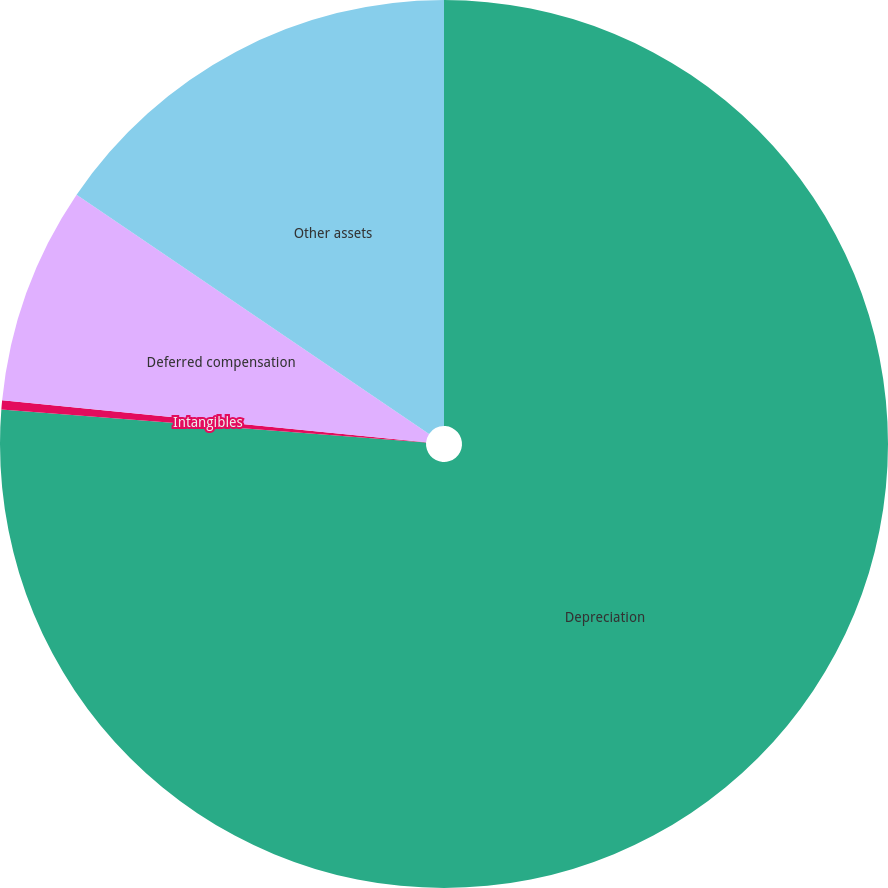<chart> <loc_0><loc_0><loc_500><loc_500><pie_chart><fcel>Depreciation<fcel>Intangibles<fcel>Deferred compensation<fcel>Other assets<nl><fcel>76.23%<fcel>0.33%<fcel>7.92%<fcel>15.51%<nl></chart> 